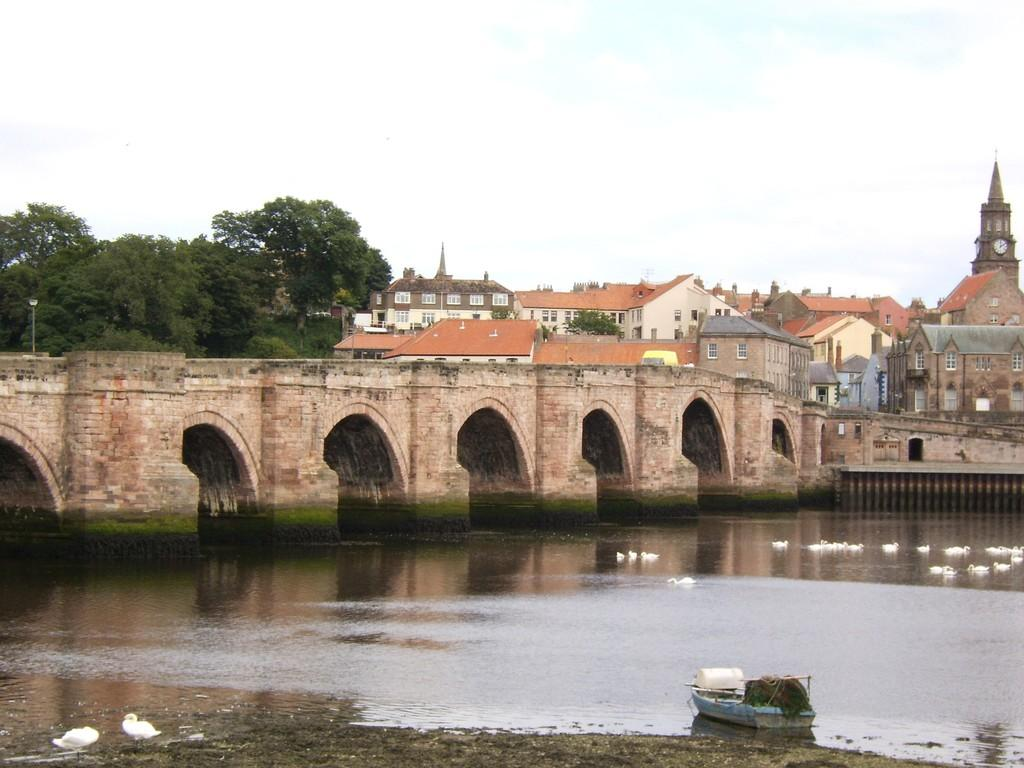What type of water feature is present in the image? There is there a canal in the image? What animals can be seen in the canal? There are ducks in the canal. What other object is present in the canal? There is a boat in the canal. What structures can be seen in the background of the image? There is a bridge and houses in the background of the image. What part of the natural environment is visible in the image? The sky is visible in the background of the image. What type of feather can be seen on the volcano in the image? There is no volcano present in the image, and therefore no feathers can be observed on it. 